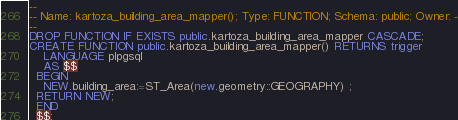<code> <loc_0><loc_0><loc_500><loc_500><_SQL_>
--
-- Name: kartoza_building_area_mapper(); Type: FUNCTION; Schema: public; Owner: -
--
DROP FUNCTION IF EXISTS public.kartoza_building_area_mapper CASCADE;
CREATE FUNCTION public.kartoza_building_area_mapper() RETURNS trigger
    LANGUAGE plpgsql
    AS $$
  BEGIN
    NEW.building_area:=ST_Area(new.geometry::GEOGRAPHY) ;
  RETURN NEW;
  END
  $$;
</code> 